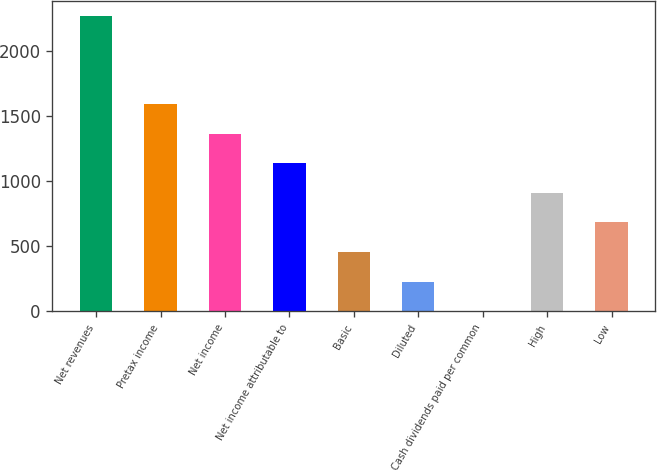<chart> <loc_0><loc_0><loc_500><loc_500><bar_chart><fcel>Net revenues<fcel>Pretax income<fcel>Net income<fcel>Net income attributable to<fcel>Basic<fcel>Diluted<fcel>Cash dividends paid per common<fcel>High<fcel>Low<nl><fcel>2271<fcel>1589.73<fcel>1362.65<fcel>1135.57<fcel>454.33<fcel>227.25<fcel>0.17<fcel>908.49<fcel>681.41<nl></chart> 